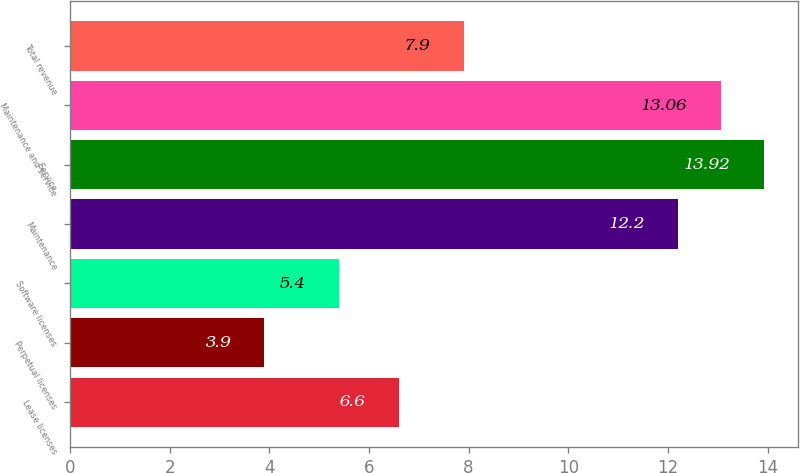Convert chart to OTSL. <chart><loc_0><loc_0><loc_500><loc_500><bar_chart><fcel>Lease licenses<fcel>Perpetual licenses<fcel>Software licenses<fcel>Maintenance<fcel>Service<fcel>Maintenance and service<fcel>Total revenue<nl><fcel>6.6<fcel>3.9<fcel>5.4<fcel>12.2<fcel>13.92<fcel>13.06<fcel>7.9<nl></chart> 